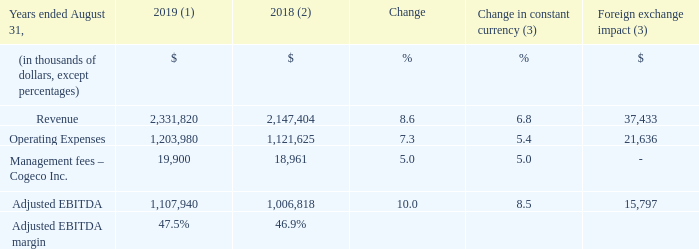3.1 OPERATING RESULTS
(1) Fiscal 2019 average foreign exchange rate used for translation was 1.3255 USD/CDN.
(2) Fiscal 2018 was restated to comply with IFRS 15 and to reflect a change in accounting policy as well as to reclassify results from Cogeco Peer 1 as discontinued
operations. For further details, please consult the "Accounting policies" and "Discontinued operations" sections.
(3) Fiscal 2019 actuals are translated at the average foreign exchange rate of fiscal 2018 which was 1.2773 USD/CDN.
What was the 2019 exchange rate? 1.3255 usd/cdn. What was the adjusted EBITDA margin in 2019? 47.5%. What was the exchange rate in 2018? 1.2773 usd/cdn. What is the increase / (decrease) in revenue from 2018 to 2019?
Answer scale should be: thousand. 2,331,820 - 2,147,404
Answer: 184416. What was the average operating expenses between 2018 and 2019?
Answer scale should be: thousand. (1,203,980 + 1,121,625) / 2
Answer: 1162802.5. What was the increase / (decrease) in the Adjusted EBITDA from 2018 to 2019?
Answer scale should be: thousand. 1,107,940 - 1,006,818
Answer: 101122. 